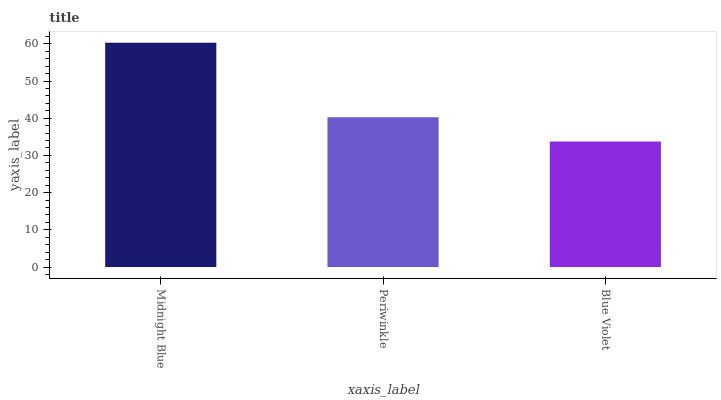Is Periwinkle the minimum?
Answer yes or no. No. Is Periwinkle the maximum?
Answer yes or no. No. Is Midnight Blue greater than Periwinkle?
Answer yes or no. Yes. Is Periwinkle less than Midnight Blue?
Answer yes or no. Yes. Is Periwinkle greater than Midnight Blue?
Answer yes or no. No. Is Midnight Blue less than Periwinkle?
Answer yes or no. No. Is Periwinkle the high median?
Answer yes or no. Yes. Is Periwinkle the low median?
Answer yes or no. Yes. Is Blue Violet the high median?
Answer yes or no. No. Is Blue Violet the low median?
Answer yes or no. No. 